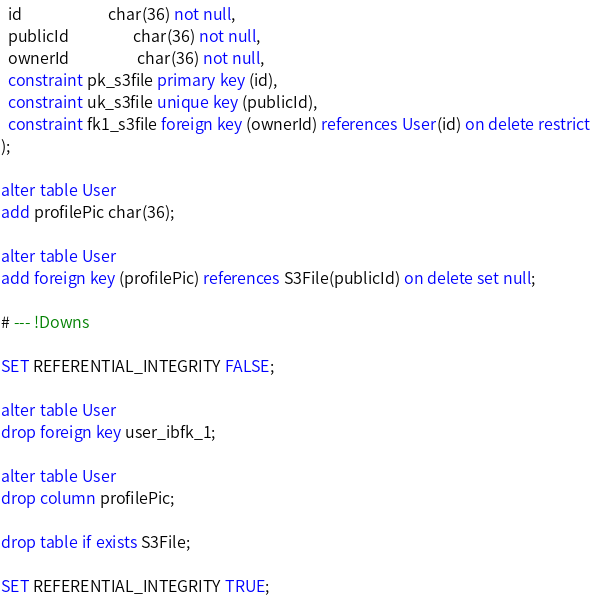<code> <loc_0><loc_0><loc_500><loc_500><_SQL_>  id                        char(36) not null,
  publicId                  char(36) not null,
  ownerId                   char(36) not null,
  constraint pk_s3file primary key (id),
  constraint uk_s3file unique key (publicId),
  constraint fk1_s3file foreign key (ownerId) references User(id) on delete restrict
);

alter table User
add profilePic char(36);

alter table User
add foreign key (profilePic) references S3File(publicId) on delete set null;

# --- !Downs

SET REFERENTIAL_INTEGRITY FALSE;

alter table User
drop foreign key user_ibfk_1;

alter table User
drop column profilePic;

drop table if exists S3File;

SET REFERENTIAL_INTEGRITY TRUE;

</code> 